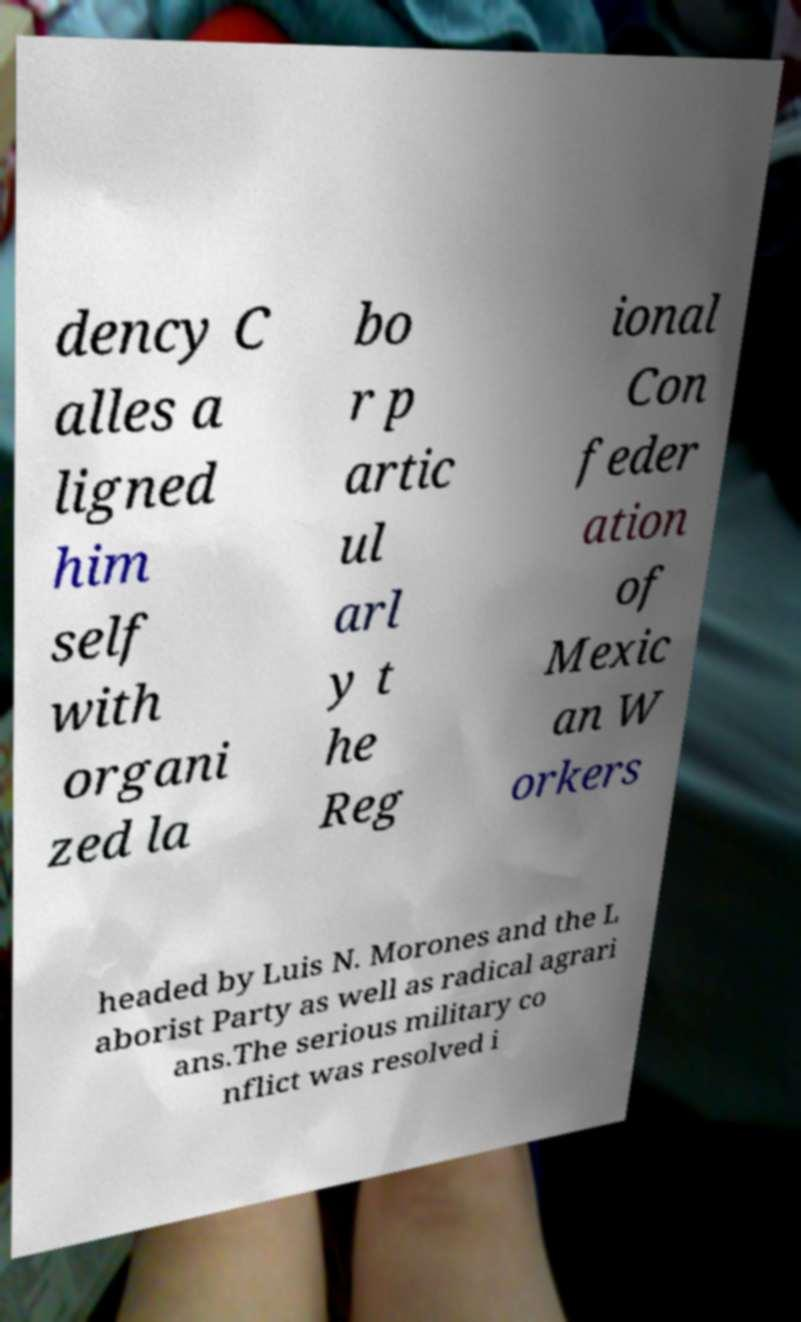For documentation purposes, I need the text within this image transcribed. Could you provide that? dency C alles a ligned him self with organi zed la bo r p artic ul arl y t he Reg ional Con feder ation of Mexic an W orkers headed by Luis N. Morones and the L aborist Party as well as radical agrari ans.The serious military co nflict was resolved i 